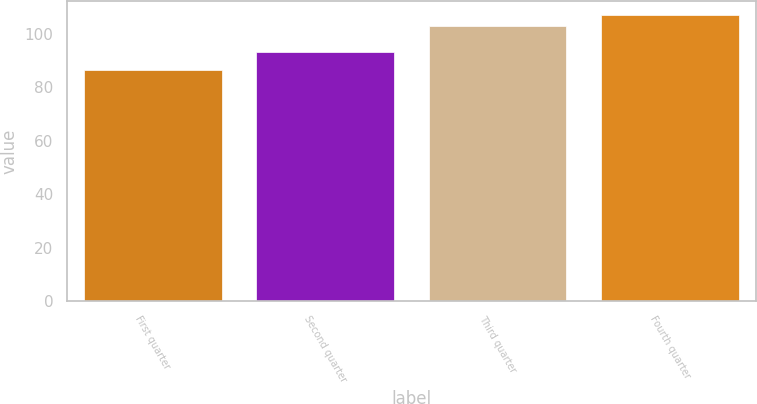<chart> <loc_0><loc_0><loc_500><loc_500><bar_chart><fcel>First quarter<fcel>Second quarter<fcel>Third quarter<fcel>Fourth quarter<nl><fcel>86.25<fcel>93.07<fcel>102.65<fcel>106.84<nl></chart> 